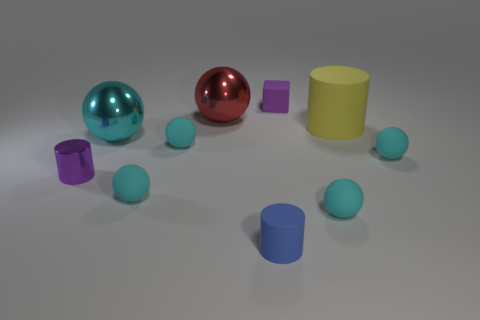Subtract all cyan spheres. How many were subtracted if there are3cyan spheres left? 2 Subtract all brown cylinders. How many cyan spheres are left? 5 Subtract all big yellow cylinders. How many cylinders are left? 2 Subtract 2 spheres. How many spheres are left? 4 Subtract all red spheres. How many spheres are left? 5 Subtract all yellow spheres. Subtract all green cubes. How many spheres are left? 6 Subtract all cubes. How many objects are left? 9 Add 8 cyan shiny objects. How many cyan shiny objects are left? 9 Add 9 purple blocks. How many purple blocks exist? 10 Subtract 1 yellow cylinders. How many objects are left? 9 